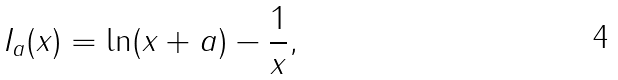Convert formula to latex. <formula><loc_0><loc_0><loc_500><loc_500>I _ { a } ( x ) = \ln ( x + a ) - \frac { 1 } { x } ,</formula> 